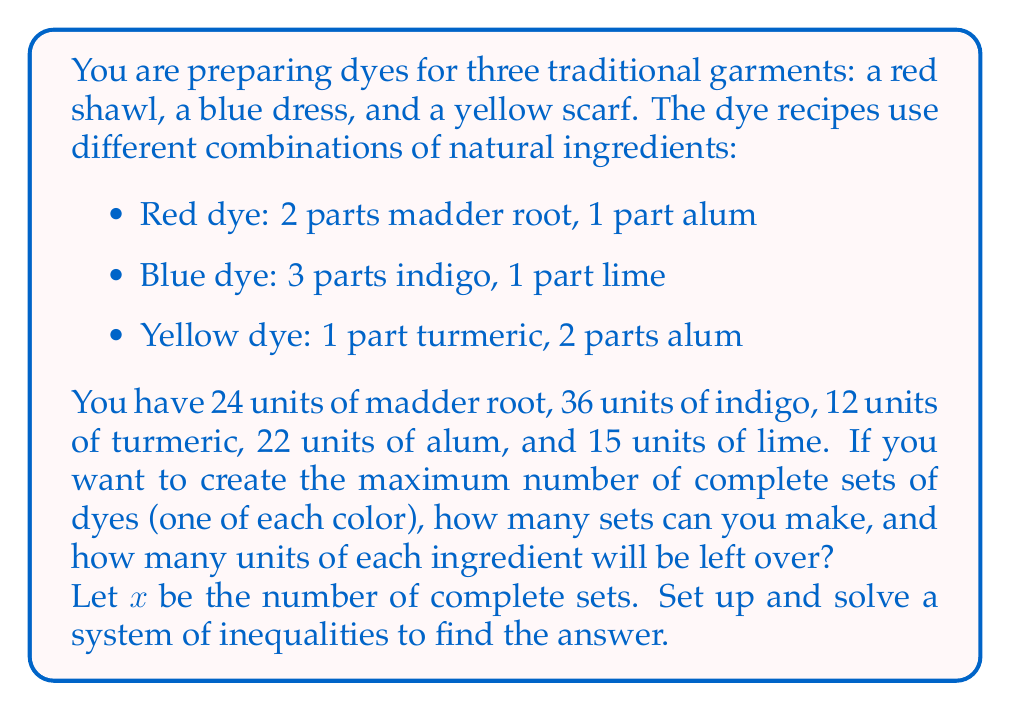Could you help me with this problem? Let's approach this step-by-step:

1) First, let's set up inequalities for each ingredient:

   Madder root: $2x \leq 24$
   Indigo: $3x \leq 36$
   Turmeric: $x \leq 12$
   Alum: $x + 2x \leq 22$ (used in red and yellow dyes)
   Lime: $x \leq 15$

2) Simplify the alum inequality:
   $3x \leq 22$

3) Now we have a system of inequalities:

   $$\begin{align}
   2x &\leq 24 \\
   3x &\leq 36 \\
   x &\leq 12 \\
   3x &\leq 22 \\
   x &\leq 15
   \end{align}$$

4) To find the maximum number of complete sets, we need to find the largest value of $x$ that satisfies all inequalities:

   $x \leq 12$ (from madder root)
   $x \leq 12$ (from indigo)
   $x \leq 12$ (from turmeric)
   $x \leq 7\frac{1}{3}$ (from alum)
   $x \leq 15$ (from lime)

5) The most restrictive inequality is $x \leq 7\frac{1}{3}$. Since $x$ must be a whole number, the maximum value is 7.

6) Now, let's calculate the leftover ingredients:

   Madder root: $24 - (2 \times 7) = 10$ units
   Indigo: $36 - (3 \times 7) = 15$ units
   Turmeric: $12 - (1 \times 7) = 5$ units
   Alum: $22 - (1 \times 7 + 2 \times 7) = 1$ unit
   Lime: $15 - (1 \times 7) = 8$ units
Answer: 7 complete sets of dyes can be made. Leftover ingredients: 10 units of madder root, 15 units of indigo, 5 units of turmeric, 1 unit of alum, and 8 units of lime. 